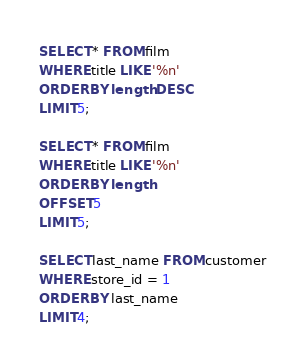Convert code to text. <code><loc_0><loc_0><loc_500><loc_500><_SQL_>SELECT * FROM film
WHERE title LIKE '%n'
ORDER BY length DESC
LIMIT 5;

SELECT * FROM film
WHERE title LIKE '%n'
ORDER BY length
OFFSET 5
LIMIT 5;

SELECT last_name FROM customer
WHERE store_id = 1
ORDER BY last_name
LIMIT 4;



</code> 